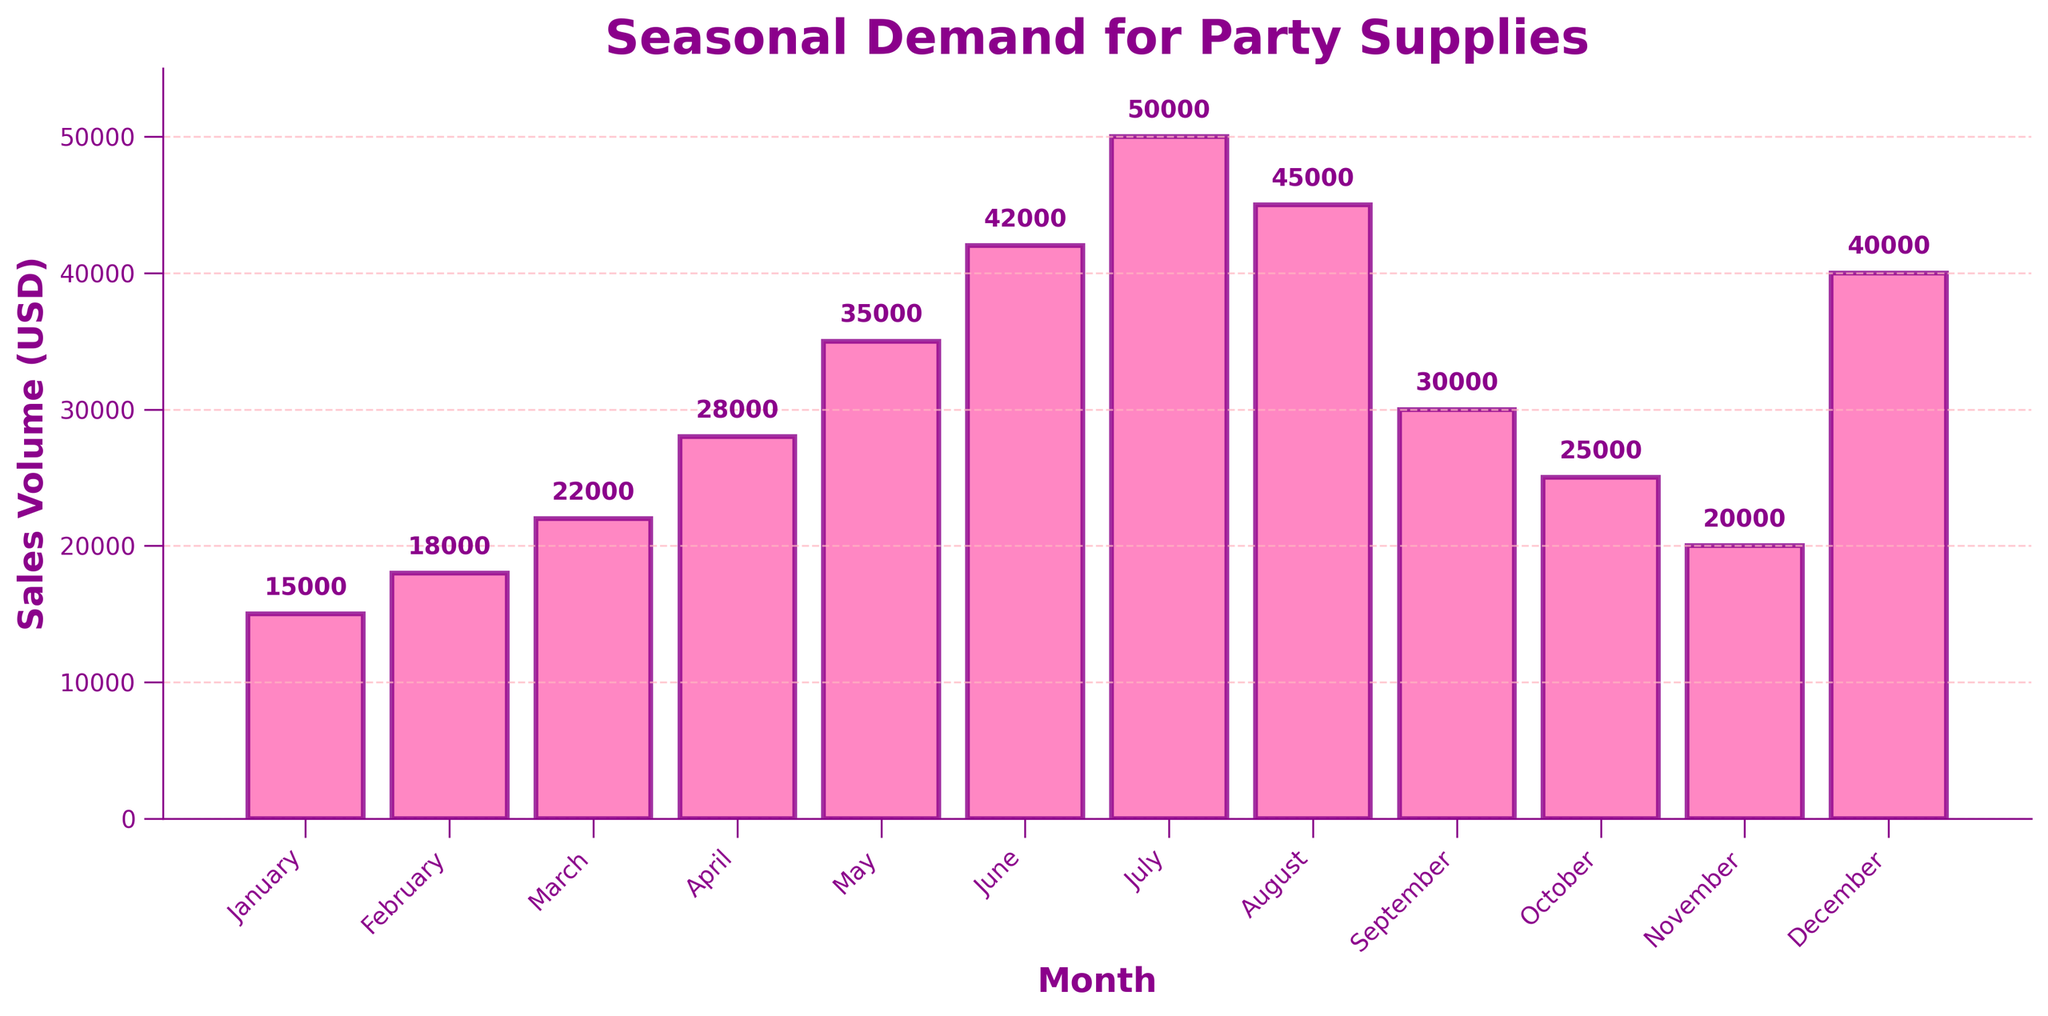Which month has the highest sales volume? Look at the bar chart and identify the tallest bar. The tallest bar corresponds to July.
Answer: July How much more were the sales in July compared to May? Find the heights of the bars corresponding to July and May. Subtract the sales volume of May (35000) from that of July (50000), which gives 50000 - 35000.
Answer: 15000 Which month had the lowest sales volume and what was it? Find the shortest bar in the bar chart, which corresponds to January with a sales volume of 15000 USD.
Answer: January, 15000 Arrange the months in descending order of sales volume. Rank the bars from highest to lowest based on their heights: July, August, June, May, December, September, April, October, March, November, February, January.
Answer: July, August, June, May, December, September, April, October, March, November, February, January What is the total sales volume for the months of June, July, and August combined? Add the sales volumes of June, July, and August: 42000 + 50000 + 45000. The sum is 137000.
Answer: 137000 What is the average sales volume for the year? Sum the sales volumes for all 12 months and then divide by 12. The sum is 350000 and the average is 350000 / 12.
Answer: 29166.67 In which month did the sales volume increase the most relative to the previous month? Calculate the difference in sales volume between consecutive months and find the largest increase: April to May (7000), May to June (7000) are the largest jumps, and since they are equal the answer is both.
Answer: May and June What is the difference in sales volume between the first and last quarters of the year? Sum the sales volumes for January to March (January + February + March = 55000) and for October to December (October + November + December = 85000). Subtract the two totals: 85000 - 55000.
Answer: 30000 Which quarter has the highest total sales volume? Sum the sales volumes for each quarter: Q1 (January to March) = 55000, Q2 (April to June) = 105000, Q3 (July to September) = 125000, Q4 (October to December) = 85000. The third quarter has the highest total.
Answer: Q3 